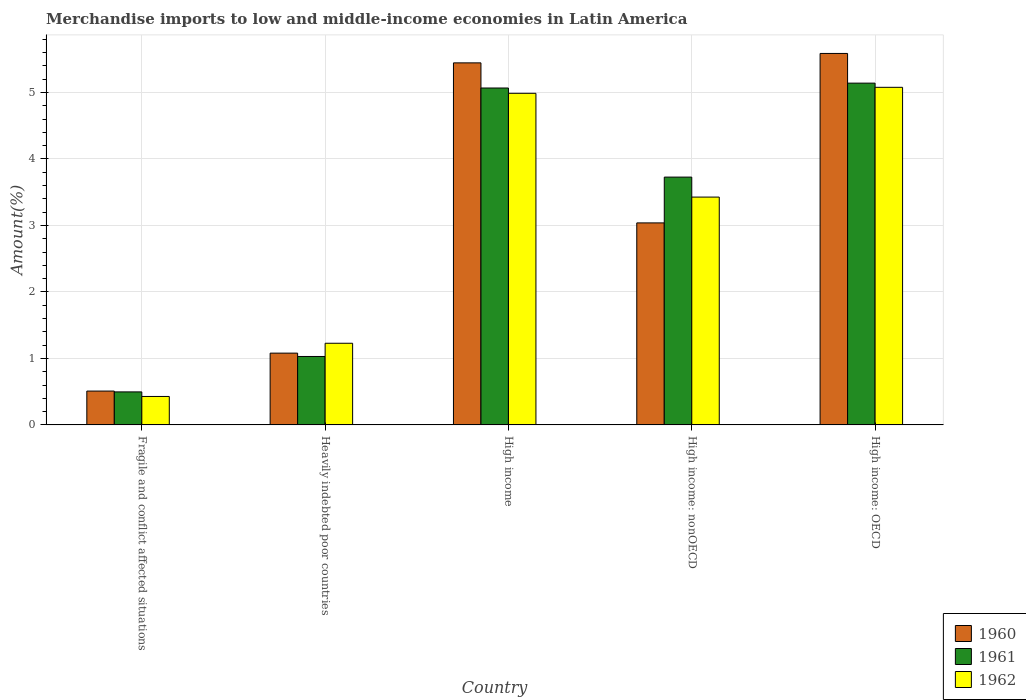How many different coloured bars are there?
Give a very brief answer. 3. Are the number of bars on each tick of the X-axis equal?
Offer a terse response. Yes. How many bars are there on the 4th tick from the left?
Offer a very short reply. 3. What is the label of the 5th group of bars from the left?
Provide a succinct answer. High income: OECD. What is the percentage of amount earned from merchandise imports in 1962 in Fragile and conflict affected situations?
Provide a succinct answer. 0.43. Across all countries, what is the maximum percentage of amount earned from merchandise imports in 1961?
Keep it short and to the point. 5.14. Across all countries, what is the minimum percentage of amount earned from merchandise imports in 1961?
Your answer should be compact. 0.5. In which country was the percentage of amount earned from merchandise imports in 1960 maximum?
Offer a very short reply. High income: OECD. In which country was the percentage of amount earned from merchandise imports in 1962 minimum?
Ensure brevity in your answer.  Fragile and conflict affected situations. What is the total percentage of amount earned from merchandise imports in 1961 in the graph?
Your answer should be compact. 15.46. What is the difference between the percentage of amount earned from merchandise imports in 1962 in Fragile and conflict affected situations and that in High income?
Offer a terse response. -4.56. What is the difference between the percentage of amount earned from merchandise imports in 1962 in High income and the percentage of amount earned from merchandise imports in 1960 in High income: OECD?
Ensure brevity in your answer.  -0.6. What is the average percentage of amount earned from merchandise imports in 1960 per country?
Provide a short and direct response. 3.13. What is the difference between the percentage of amount earned from merchandise imports of/in 1962 and percentage of amount earned from merchandise imports of/in 1961 in Heavily indebted poor countries?
Provide a short and direct response. 0.2. What is the ratio of the percentage of amount earned from merchandise imports in 1960 in Heavily indebted poor countries to that in High income?
Give a very brief answer. 0.2. Is the difference between the percentage of amount earned from merchandise imports in 1962 in Heavily indebted poor countries and High income: nonOECD greater than the difference between the percentage of amount earned from merchandise imports in 1961 in Heavily indebted poor countries and High income: nonOECD?
Make the answer very short. Yes. What is the difference between the highest and the second highest percentage of amount earned from merchandise imports in 1962?
Ensure brevity in your answer.  -1.56. What is the difference between the highest and the lowest percentage of amount earned from merchandise imports in 1960?
Provide a short and direct response. 5.08. Is the sum of the percentage of amount earned from merchandise imports in 1960 in High income and High income: nonOECD greater than the maximum percentage of amount earned from merchandise imports in 1961 across all countries?
Offer a very short reply. Yes. What does the 3rd bar from the right in Heavily indebted poor countries represents?
Your response must be concise. 1960. Is it the case that in every country, the sum of the percentage of amount earned from merchandise imports in 1961 and percentage of amount earned from merchandise imports in 1960 is greater than the percentage of amount earned from merchandise imports in 1962?
Give a very brief answer. Yes. How many bars are there?
Provide a succinct answer. 15. Are the values on the major ticks of Y-axis written in scientific E-notation?
Keep it short and to the point. No. Does the graph contain grids?
Offer a very short reply. Yes. Where does the legend appear in the graph?
Your answer should be compact. Bottom right. How many legend labels are there?
Provide a succinct answer. 3. What is the title of the graph?
Provide a succinct answer. Merchandise imports to low and middle-income economies in Latin America. What is the label or title of the Y-axis?
Keep it short and to the point. Amount(%). What is the Amount(%) in 1960 in Fragile and conflict affected situations?
Give a very brief answer. 0.51. What is the Amount(%) of 1961 in Fragile and conflict affected situations?
Offer a very short reply. 0.5. What is the Amount(%) in 1962 in Fragile and conflict affected situations?
Your response must be concise. 0.43. What is the Amount(%) in 1960 in Heavily indebted poor countries?
Ensure brevity in your answer.  1.08. What is the Amount(%) in 1961 in Heavily indebted poor countries?
Keep it short and to the point. 1.03. What is the Amount(%) in 1962 in Heavily indebted poor countries?
Keep it short and to the point. 1.23. What is the Amount(%) of 1960 in High income?
Your response must be concise. 5.44. What is the Amount(%) in 1961 in High income?
Give a very brief answer. 5.07. What is the Amount(%) of 1962 in High income?
Your response must be concise. 4.99. What is the Amount(%) of 1960 in High income: nonOECD?
Offer a very short reply. 3.04. What is the Amount(%) of 1961 in High income: nonOECD?
Your response must be concise. 3.73. What is the Amount(%) in 1962 in High income: nonOECD?
Ensure brevity in your answer.  3.43. What is the Amount(%) in 1960 in High income: OECD?
Offer a very short reply. 5.59. What is the Amount(%) in 1961 in High income: OECD?
Provide a short and direct response. 5.14. What is the Amount(%) of 1962 in High income: OECD?
Offer a terse response. 5.08. Across all countries, what is the maximum Amount(%) of 1960?
Offer a very short reply. 5.59. Across all countries, what is the maximum Amount(%) in 1961?
Make the answer very short. 5.14. Across all countries, what is the maximum Amount(%) in 1962?
Ensure brevity in your answer.  5.08. Across all countries, what is the minimum Amount(%) in 1960?
Your answer should be very brief. 0.51. Across all countries, what is the minimum Amount(%) in 1961?
Offer a terse response. 0.5. Across all countries, what is the minimum Amount(%) in 1962?
Keep it short and to the point. 0.43. What is the total Amount(%) in 1960 in the graph?
Your answer should be very brief. 15.66. What is the total Amount(%) of 1961 in the graph?
Make the answer very short. 15.46. What is the total Amount(%) in 1962 in the graph?
Your answer should be compact. 15.14. What is the difference between the Amount(%) of 1960 in Fragile and conflict affected situations and that in Heavily indebted poor countries?
Give a very brief answer. -0.57. What is the difference between the Amount(%) in 1961 in Fragile and conflict affected situations and that in Heavily indebted poor countries?
Your response must be concise. -0.53. What is the difference between the Amount(%) of 1962 in Fragile and conflict affected situations and that in Heavily indebted poor countries?
Your answer should be very brief. -0.8. What is the difference between the Amount(%) in 1960 in Fragile and conflict affected situations and that in High income?
Ensure brevity in your answer.  -4.94. What is the difference between the Amount(%) in 1961 in Fragile and conflict affected situations and that in High income?
Give a very brief answer. -4.57. What is the difference between the Amount(%) of 1962 in Fragile and conflict affected situations and that in High income?
Provide a short and direct response. -4.56. What is the difference between the Amount(%) in 1960 in Fragile and conflict affected situations and that in High income: nonOECD?
Provide a succinct answer. -2.53. What is the difference between the Amount(%) in 1961 in Fragile and conflict affected situations and that in High income: nonOECD?
Keep it short and to the point. -3.23. What is the difference between the Amount(%) in 1962 in Fragile and conflict affected situations and that in High income: nonOECD?
Your answer should be very brief. -3. What is the difference between the Amount(%) in 1960 in Fragile and conflict affected situations and that in High income: OECD?
Give a very brief answer. -5.08. What is the difference between the Amount(%) in 1961 in Fragile and conflict affected situations and that in High income: OECD?
Your response must be concise. -4.64. What is the difference between the Amount(%) in 1962 in Fragile and conflict affected situations and that in High income: OECD?
Make the answer very short. -4.65. What is the difference between the Amount(%) of 1960 in Heavily indebted poor countries and that in High income?
Provide a succinct answer. -4.36. What is the difference between the Amount(%) in 1961 in Heavily indebted poor countries and that in High income?
Offer a terse response. -4.04. What is the difference between the Amount(%) of 1962 in Heavily indebted poor countries and that in High income?
Provide a succinct answer. -3.76. What is the difference between the Amount(%) of 1960 in Heavily indebted poor countries and that in High income: nonOECD?
Your answer should be compact. -1.96. What is the difference between the Amount(%) in 1961 in Heavily indebted poor countries and that in High income: nonOECD?
Give a very brief answer. -2.7. What is the difference between the Amount(%) of 1962 in Heavily indebted poor countries and that in High income: nonOECD?
Your answer should be compact. -2.2. What is the difference between the Amount(%) in 1960 in Heavily indebted poor countries and that in High income: OECD?
Your response must be concise. -4.51. What is the difference between the Amount(%) of 1961 in Heavily indebted poor countries and that in High income: OECD?
Make the answer very short. -4.11. What is the difference between the Amount(%) in 1962 in Heavily indebted poor countries and that in High income: OECD?
Give a very brief answer. -3.85. What is the difference between the Amount(%) in 1960 in High income and that in High income: nonOECD?
Offer a very short reply. 2.41. What is the difference between the Amount(%) in 1961 in High income and that in High income: nonOECD?
Make the answer very short. 1.34. What is the difference between the Amount(%) in 1962 in High income and that in High income: nonOECD?
Provide a succinct answer. 1.56. What is the difference between the Amount(%) in 1960 in High income and that in High income: OECD?
Your response must be concise. -0.14. What is the difference between the Amount(%) in 1961 in High income and that in High income: OECD?
Offer a very short reply. -0.07. What is the difference between the Amount(%) in 1962 in High income and that in High income: OECD?
Provide a succinct answer. -0.09. What is the difference between the Amount(%) of 1960 in High income: nonOECD and that in High income: OECD?
Ensure brevity in your answer.  -2.55. What is the difference between the Amount(%) of 1961 in High income: nonOECD and that in High income: OECD?
Keep it short and to the point. -1.41. What is the difference between the Amount(%) in 1962 in High income: nonOECD and that in High income: OECD?
Ensure brevity in your answer.  -1.65. What is the difference between the Amount(%) in 1960 in Fragile and conflict affected situations and the Amount(%) in 1961 in Heavily indebted poor countries?
Your response must be concise. -0.52. What is the difference between the Amount(%) in 1960 in Fragile and conflict affected situations and the Amount(%) in 1962 in Heavily indebted poor countries?
Offer a terse response. -0.72. What is the difference between the Amount(%) of 1961 in Fragile and conflict affected situations and the Amount(%) of 1962 in Heavily indebted poor countries?
Your answer should be very brief. -0.73. What is the difference between the Amount(%) in 1960 in Fragile and conflict affected situations and the Amount(%) in 1961 in High income?
Your answer should be very brief. -4.56. What is the difference between the Amount(%) in 1960 in Fragile and conflict affected situations and the Amount(%) in 1962 in High income?
Ensure brevity in your answer.  -4.48. What is the difference between the Amount(%) in 1961 in Fragile and conflict affected situations and the Amount(%) in 1962 in High income?
Your answer should be very brief. -4.49. What is the difference between the Amount(%) in 1960 in Fragile and conflict affected situations and the Amount(%) in 1961 in High income: nonOECD?
Provide a short and direct response. -3.22. What is the difference between the Amount(%) of 1960 in Fragile and conflict affected situations and the Amount(%) of 1962 in High income: nonOECD?
Provide a short and direct response. -2.92. What is the difference between the Amount(%) in 1961 in Fragile and conflict affected situations and the Amount(%) in 1962 in High income: nonOECD?
Make the answer very short. -2.93. What is the difference between the Amount(%) of 1960 in Fragile and conflict affected situations and the Amount(%) of 1961 in High income: OECD?
Provide a short and direct response. -4.63. What is the difference between the Amount(%) in 1960 in Fragile and conflict affected situations and the Amount(%) in 1962 in High income: OECD?
Provide a short and direct response. -4.57. What is the difference between the Amount(%) of 1961 in Fragile and conflict affected situations and the Amount(%) of 1962 in High income: OECD?
Offer a terse response. -4.58. What is the difference between the Amount(%) in 1960 in Heavily indebted poor countries and the Amount(%) in 1961 in High income?
Your answer should be compact. -3.99. What is the difference between the Amount(%) of 1960 in Heavily indebted poor countries and the Amount(%) of 1962 in High income?
Your answer should be very brief. -3.91. What is the difference between the Amount(%) in 1961 in Heavily indebted poor countries and the Amount(%) in 1962 in High income?
Your response must be concise. -3.96. What is the difference between the Amount(%) of 1960 in Heavily indebted poor countries and the Amount(%) of 1961 in High income: nonOECD?
Give a very brief answer. -2.65. What is the difference between the Amount(%) in 1960 in Heavily indebted poor countries and the Amount(%) in 1962 in High income: nonOECD?
Keep it short and to the point. -2.35. What is the difference between the Amount(%) in 1961 in Heavily indebted poor countries and the Amount(%) in 1962 in High income: nonOECD?
Offer a very short reply. -2.4. What is the difference between the Amount(%) in 1960 in Heavily indebted poor countries and the Amount(%) in 1961 in High income: OECD?
Your answer should be very brief. -4.06. What is the difference between the Amount(%) in 1960 in Heavily indebted poor countries and the Amount(%) in 1962 in High income: OECD?
Keep it short and to the point. -4. What is the difference between the Amount(%) in 1961 in Heavily indebted poor countries and the Amount(%) in 1962 in High income: OECD?
Offer a terse response. -4.05. What is the difference between the Amount(%) of 1960 in High income and the Amount(%) of 1961 in High income: nonOECD?
Offer a terse response. 1.72. What is the difference between the Amount(%) in 1960 in High income and the Amount(%) in 1962 in High income: nonOECD?
Make the answer very short. 2.02. What is the difference between the Amount(%) in 1961 in High income and the Amount(%) in 1962 in High income: nonOECD?
Ensure brevity in your answer.  1.64. What is the difference between the Amount(%) in 1960 in High income and the Amount(%) in 1961 in High income: OECD?
Provide a short and direct response. 0.3. What is the difference between the Amount(%) in 1960 in High income and the Amount(%) in 1962 in High income: OECD?
Your answer should be very brief. 0.37. What is the difference between the Amount(%) of 1961 in High income and the Amount(%) of 1962 in High income: OECD?
Make the answer very short. -0.01. What is the difference between the Amount(%) of 1960 in High income: nonOECD and the Amount(%) of 1961 in High income: OECD?
Provide a succinct answer. -2.1. What is the difference between the Amount(%) of 1960 in High income: nonOECD and the Amount(%) of 1962 in High income: OECD?
Ensure brevity in your answer.  -2.04. What is the difference between the Amount(%) of 1961 in High income: nonOECD and the Amount(%) of 1962 in High income: OECD?
Your answer should be compact. -1.35. What is the average Amount(%) in 1960 per country?
Provide a short and direct response. 3.13. What is the average Amount(%) of 1961 per country?
Offer a terse response. 3.09. What is the average Amount(%) in 1962 per country?
Offer a very short reply. 3.03. What is the difference between the Amount(%) of 1960 and Amount(%) of 1961 in Fragile and conflict affected situations?
Make the answer very short. 0.01. What is the difference between the Amount(%) of 1960 and Amount(%) of 1962 in Fragile and conflict affected situations?
Keep it short and to the point. 0.08. What is the difference between the Amount(%) of 1961 and Amount(%) of 1962 in Fragile and conflict affected situations?
Keep it short and to the point. 0.07. What is the difference between the Amount(%) of 1960 and Amount(%) of 1961 in Heavily indebted poor countries?
Provide a succinct answer. 0.05. What is the difference between the Amount(%) in 1960 and Amount(%) in 1962 in Heavily indebted poor countries?
Offer a terse response. -0.15. What is the difference between the Amount(%) in 1961 and Amount(%) in 1962 in Heavily indebted poor countries?
Give a very brief answer. -0.2. What is the difference between the Amount(%) in 1960 and Amount(%) in 1961 in High income?
Provide a succinct answer. 0.38. What is the difference between the Amount(%) of 1960 and Amount(%) of 1962 in High income?
Ensure brevity in your answer.  0.46. What is the difference between the Amount(%) of 1961 and Amount(%) of 1962 in High income?
Give a very brief answer. 0.08. What is the difference between the Amount(%) of 1960 and Amount(%) of 1961 in High income: nonOECD?
Your answer should be very brief. -0.69. What is the difference between the Amount(%) in 1960 and Amount(%) in 1962 in High income: nonOECD?
Keep it short and to the point. -0.39. What is the difference between the Amount(%) of 1961 and Amount(%) of 1962 in High income: nonOECD?
Provide a short and direct response. 0.3. What is the difference between the Amount(%) of 1960 and Amount(%) of 1961 in High income: OECD?
Provide a short and direct response. 0.45. What is the difference between the Amount(%) of 1960 and Amount(%) of 1962 in High income: OECD?
Your answer should be very brief. 0.51. What is the difference between the Amount(%) of 1961 and Amount(%) of 1962 in High income: OECD?
Offer a very short reply. 0.06. What is the ratio of the Amount(%) in 1960 in Fragile and conflict affected situations to that in Heavily indebted poor countries?
Keep it short and to the point. 0.47. What is the ratio of the Amount(%) in 1961 in Fragile and conflict affected situations to that in Heavily indebted poor countries?
Offer a terse response. 0.48. What is the ratio of the Amount(%) of 1962 in Fragile and conflict affected situations to that in Heavily indebted poor countries?
Make the answer very short. 0.35. What is the ratio of the Amount(%) of 1960 in Fragile and conflict affected situations to that in High income?
Make the answer very short. 0.09. What is the ratio of the Amount(%) in 1961 in Fragile and conflict affected situations to that in High income?
Your response must be concise. 0.1. What is the ratio of the Amount(%) in 1962 in Fragile and conflict affected situations to that in High income?
Provide a short and direct response. 0.09. What is the ratio of the Amount(%) in 1960 in Fragile and conflict affected situations to that in High income: nonOECD?
Make the answer very short. 0.17. What is the ratio of the Amount(%) of 1961 in Fragile and conflict affected situations to that in High income: nonOECD?
Keep it short and to the point. 0.13. What is the ratio of the Amount(%) of 1962 in Fragile and conflict affected situations to that in High income: nonOECD?
Your answer should be very brief. 0.12. What is the ratio of the Amount(%) of 1960 in Fragile and conflict affected situations to that in High income: OECD?
Provide a succinct answer. 0.09. What is the ratio of the Amount(%) of 1961 in Fragile and conflict affected situations to that in High income: OECD?
Give a very brief answer. 0.1. What is the ratio of the Amount(%) in 1962 in Fragile and conflict affected situations to that in High income: OECD?
Offer a very short reply. 0.08. What is the ratio of the Amount(%) of 1960 in Heavily indebted poor countries to that in High income?
Give a very brief answer. 0.2. What is the ratio of the Amount(%) of 1961 in Heavily indebted poor countries to that in High income?
Provide a succinct answer. 0.2. What is the ratio of the Amount(%) of 1962 in Heavily indebted poor countries to that in High income?
Provide a short and direct response. 0.25. What is the ratio of the Amount(%) in 1960 in Heavily indebted poor countries to that in High income: nonOECD?
Your answer should be very brief. 0.36. What is the ratio of the Amount(%) of 1961 in Heavily indebted poor countries to that in High income: nonOECD?
Offer a very short reply. 0.28. What is the ratio of the Amount(%) in 1962 in Heavily indebted poor countries to that in High income: nonOECD?
Your response must be concise. 0.36. What is the ratio of the Amount(%) in 1960 in Heavily indebted poor countries to that in High income: OECD?
Offer a very short reply. 0.19. What is the ratio of the Amount(%) of 1961 in Heavily indebted poor countries to that in High income: OECD?
Offer a very short reply. 0.2. What is the ratio of the Amount(%) in 1962 in Heavily indebted poor countries to that in High income: OECD?
Offer a very short reply. 0.24. What is the ratio of the Amount(%) of 1960 in High income to that in High income: nonOECD?
Ensure brevity in your answer.  1.79. What is the ratio of the Amount(%) in 1961 in High income to that in High income: nonOECD?
Your response must be concise. 1.36. What is the ratio of the Amount(%) in 1962 in High income to that in High income: nonOECD?
Your answer should be very brief. 1.46. What is the ratio of the Amount(%) of 1960 in High income to that in High income: OECD?
Your response must be concise. 0.97. What is the ratio of the Amount(%) in 1961 in High income to that in High income: OECD?
Ensure brevity in your answer.  0.99. What is the ratio of the Amount(%) in 1962 in High income to that in High income: OECD?
Your answer should be compact. 0.98. What is the ratio of the Amount(%) in 1960 in High income: nonOECD to that in High income: OECD?
Provide a short and direct response. 0.54. What is the ratio of the Amount(%) in 1961 in High income: nonOECD to that in High income: OECD?
Your answer should be compact. 0.73. What is the ratio of the Amount(%) of 1962 in High income: nonOECD to that in High income: OECD?
Your response must be concise. 0.67. What is the difference between the highest and the second highest Amount(%) of 1960?
Provide a succinct answer. 0.14. What is the difference between the highest and the second highest Amount(%) in 1961?
Your answer should be very brief. 0.07. What is the difference between the highest and the second highest Amount(%) in 1962?
Your response must be concise. 0.09. What is the difference between the highest and the lowest Amount(%) in 1960?
Your answer should be very brief. 5.08. What is the difference between the highest and the lowest Amount(%) in 1961?
Your response must be concise. 4.64. What is the difference between the highest and the lowest Amount(%) in 1962?
Provide a succinct answer. 4.65. 